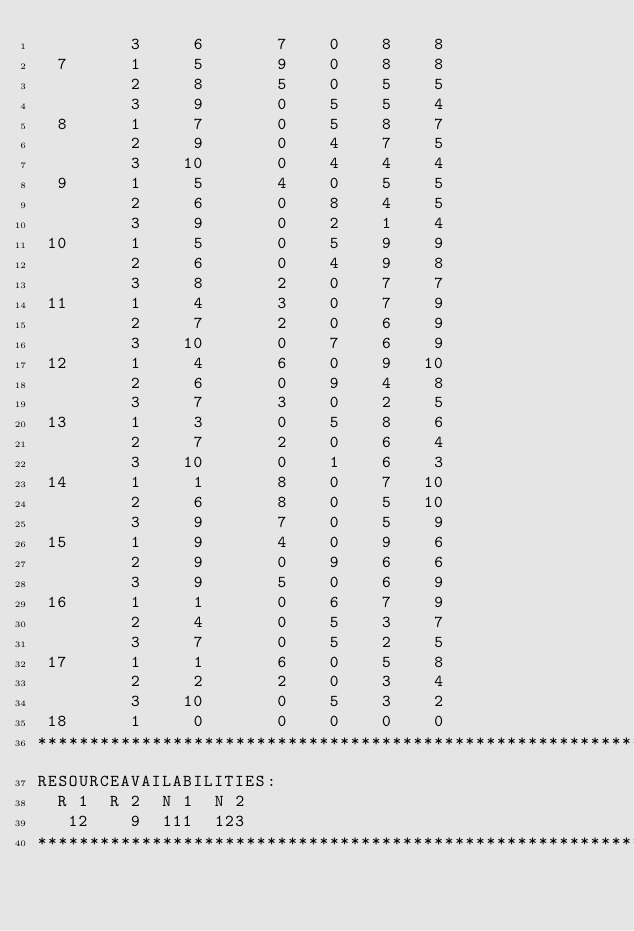<code> <loc_0><loc_0><loc_500><loc_500><_ObjectiveC_>         3     6       7    0    8    8
  7      1     5       9    0    8    8
         2     8       5    0    5    5
         3     9       0    5    5    4
  8      1     7       0    5    8    7
         2     9       0    4    7    5
         3    10       0    4    4    4
  9      1     5       4    0    5    5
         2     6       0    8    4    5
         3     9       0    2    1    4
 10      1     5       0    5    9    9
         2     6       0    4    9    8
         3     8       2    0    7    7
 11      1     4       3    0    7    9
         2     7       2    0    6    9
         3    10       0    7    6    9
 12      1     4       6    0    9   10
         2     6       0    9    4    8
         3     7       3    0    2    5
 13      1     3       0    5    8    6
         2     7       2    0    6    4
         3    10       0    1    6    3
 14      1     1       8    0    7   10
         2     6       8    0    5   10
         3     9       7    0    5    9
 15      1     9       4    0    9    6
         2     9       0    9    6    6
         3     9       5    0    6    9
 16      1     1       0    6    7    9
         2     4       0    5    3    7
         3     7       0    5    2    5
 17      1     1       6    0    5    8
         2     2       2    0    3    4
         3    10       0    5    3    2
 18      1     0       0    0    0    0
************************************************************************
RESOURCEAVAILABILITIES:
  R 1  R 2  N 1  N 2
   12    9  111  123
************************************************************************
</code> 